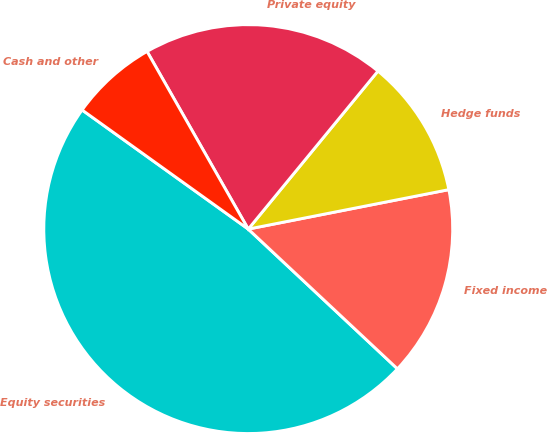Convert chart. <chart><loc_0><loc_0><loc_500><loc_500><pie_chart><fcel>Equity securities<fcel>Fixed income<fcel>Hedge funds<fcel>Private equity<fcel>Cash and other<nl><fcel>47.92%<fcel>15.07%<fcel>10.97%<fcel>19.18%<fcel>6.86%<nl></chart> 